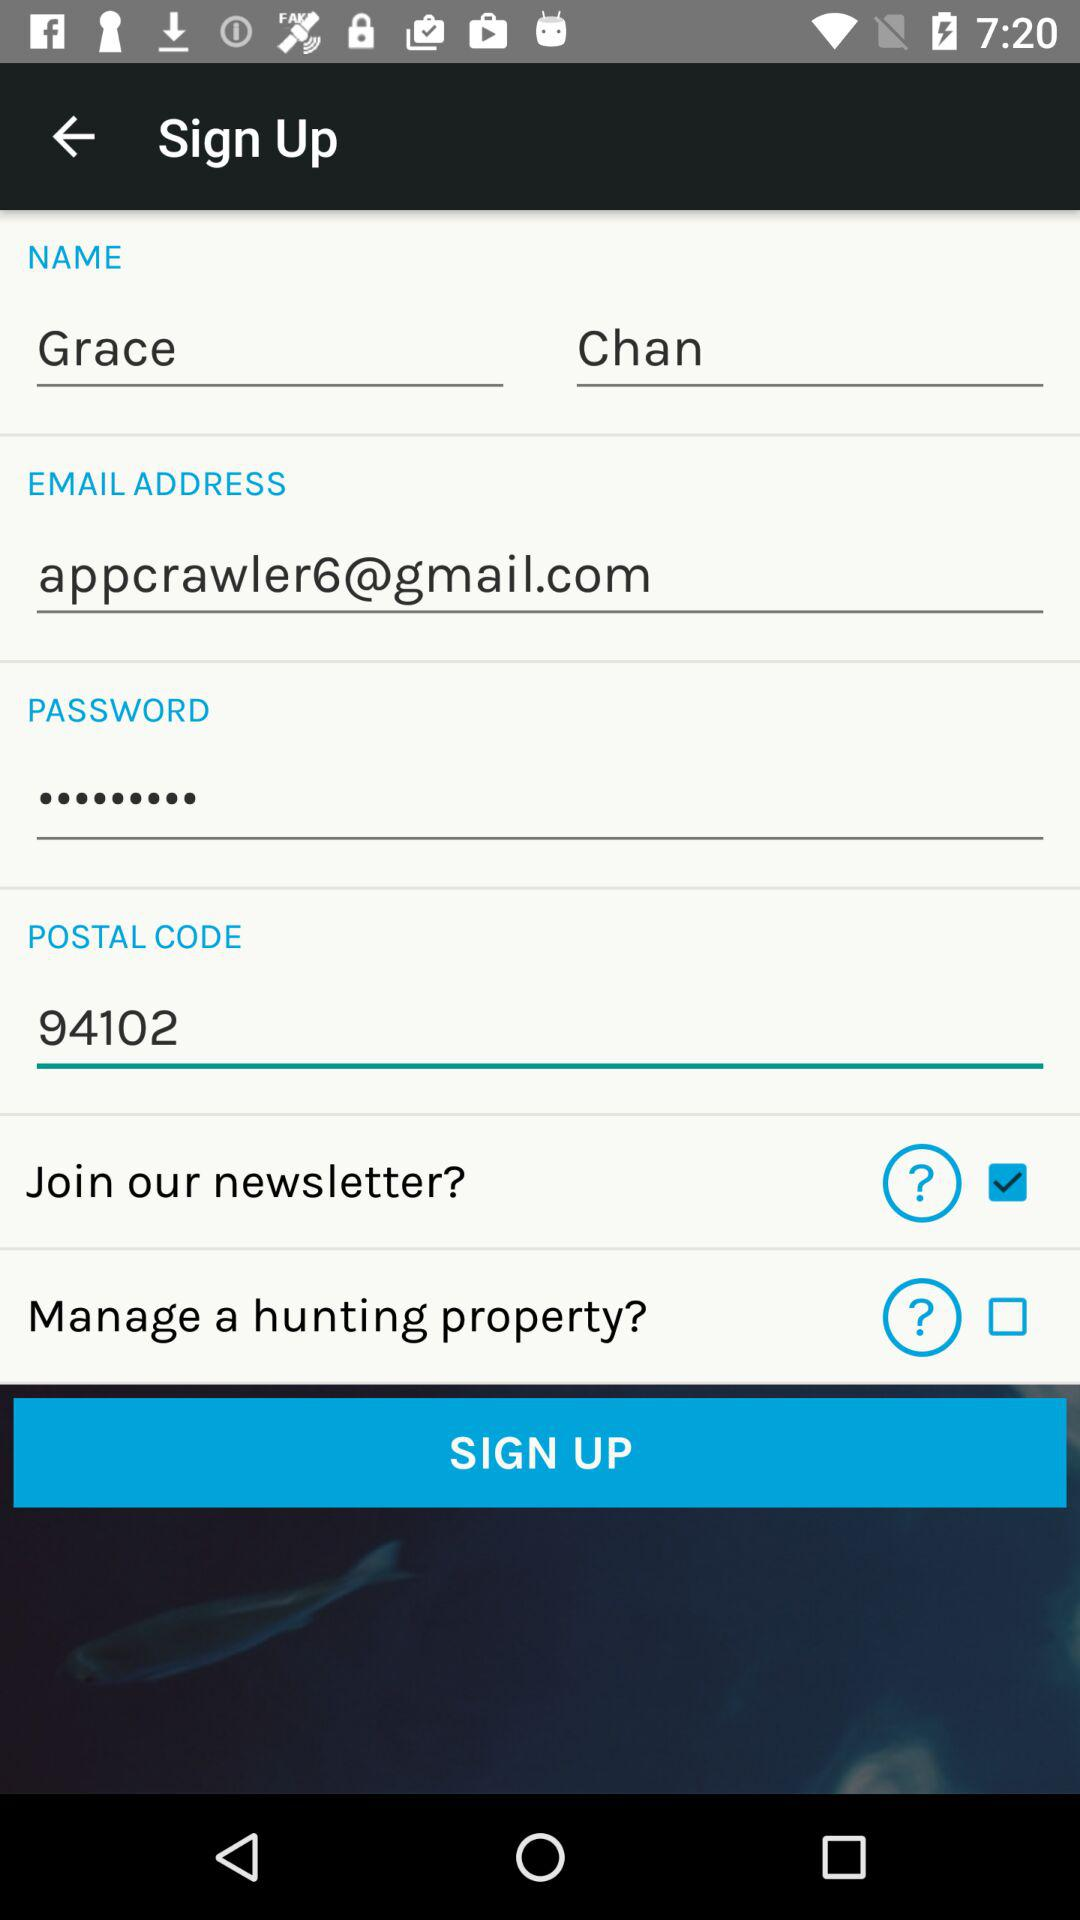What is the user name? The user name is Grace Chan. 